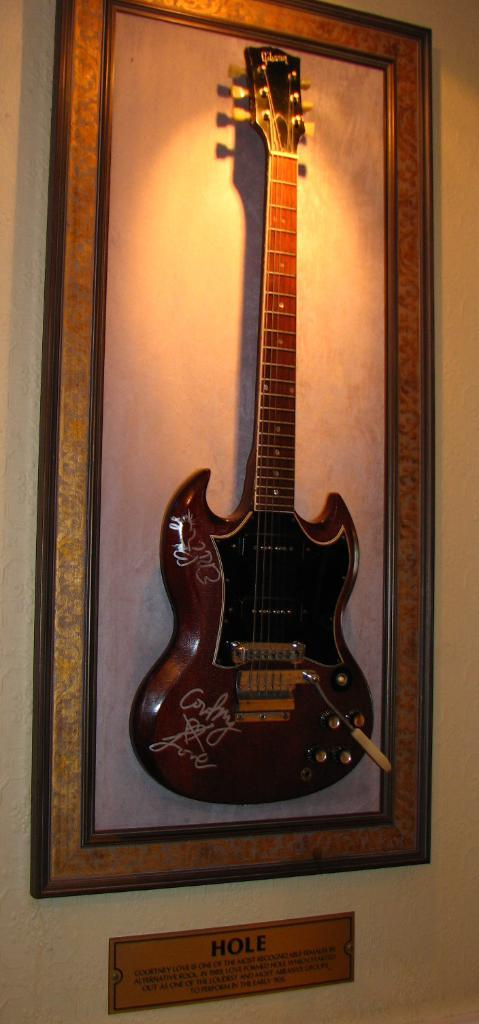<image>
Relay a brief, clear account of the picture shown. Framed guitar that has a sign below it that says HOLE. 